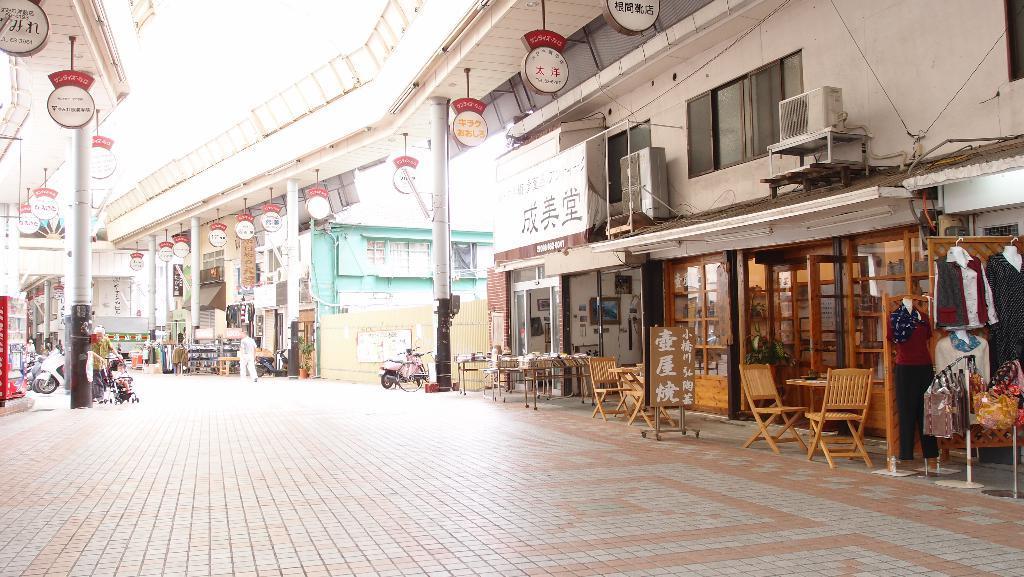Could you give a brief overview of what you see in this image? In this image on the right side there are buildings and on the roof of the building there are boards hanging and there are pillars. In front of the building in the front on the right side there are tables, empty chairs and there are clothes and there are AC outdoor units. In the center there is a person walking and on the left side there is a pillar and on the top there are boards hanging, there are vehicles, there is a refrigerator. In the background there are objects which are black and brown in colour. 